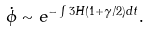Convert formula to latex. <formula><loc_0><loc_0><loc_500><loc_500>\dot { \phi } \sim e ^ { - \int { 3 H ( 1 + \gamma / 2 ) d t } } .</formula> 